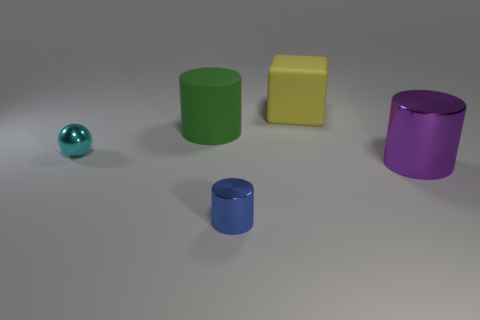Subtract all shiny cylinders. How many cylinders are left? 1 Subtract all green cylinders. How many cylinders are left? 2 Subtract all cylinders. How many objects are left? 2 Add 4 big blue metallic balls. How many big blue metallic balls exist? 4 Add 3 big green shiny spheres. How many objects exist? 8 Subtract 1 cyan balls. How many objects are left? 4 Subtract all purple cylinders. Subtract all cyan spheres. How many cylinders are left? 2 Subtract all gray rubber objects. Subtract all big blocks. How many objects are left? 4 Add 2 rubber things. How many rubber things are left? 4 